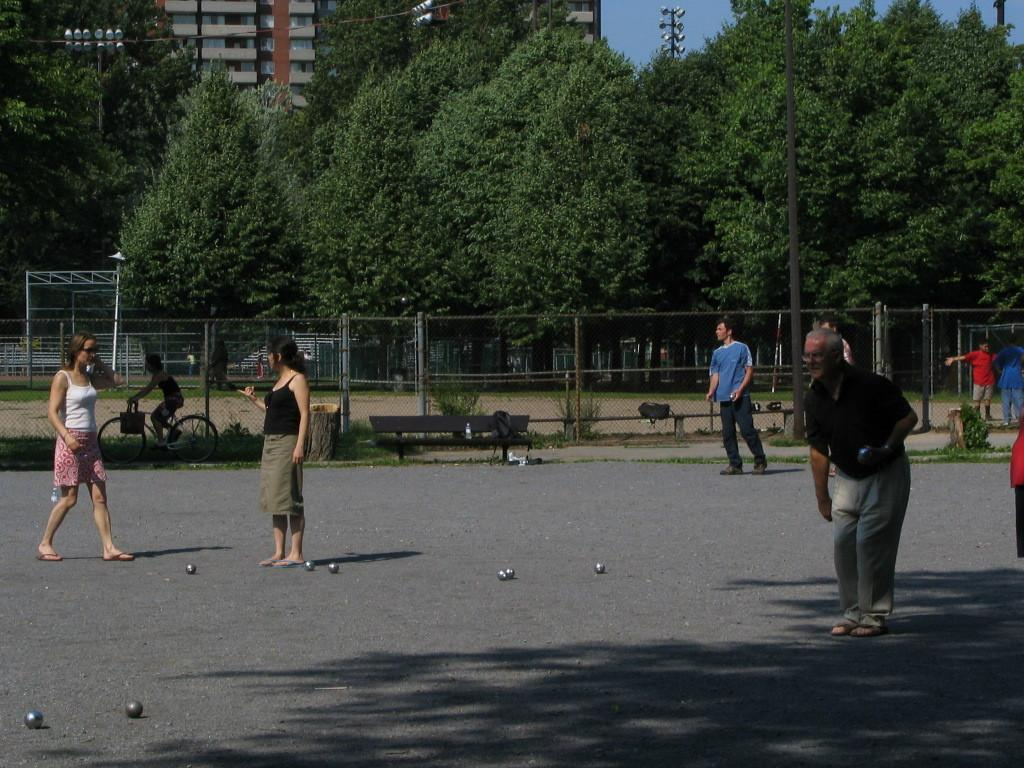How many people are present in the image? There are people in the image, but the exact number is not specified. What objects are present along with the people? There are balls in the image. Where are the people and balls located? The people and balls are on the road. What can be seen in the background of the image? In the background of the image, there is a fence, benches, trees, light poles, and a building. What is a person doing in the image? A person is sitting on a bicycle. What is attached to the bicycle? The bicycle has a bag attached to it. How many oranges are being used as a bat in the image? There are no oranges or bats present in the image. 